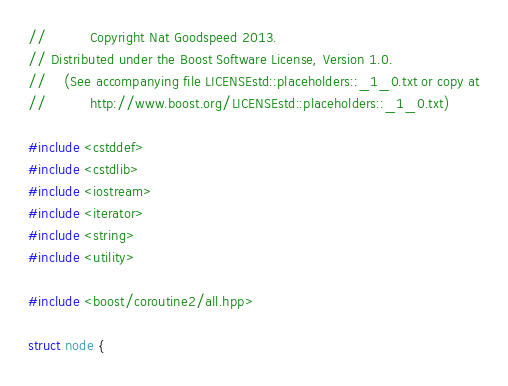<code> <loc_0><loc_0><loc_500><loc_500><_C++_>
//          Copyright Nat Goodspeed 2013.
// Distributed under the Boost Software License, Version 1.0.
//    (See accompanying file LICENSEstd::placeholders::_1_0.txt or copy at
//          http://www.boost.org/LICENSEstd::placeholders::_1_0.txt)

#include <cstddef>
#include <cstdlib>
#include <iostream>
#include <iterator>
#include <string>
#include <utility>

#include <boost/coroutine2/all.hpp>

struct node {</code> 